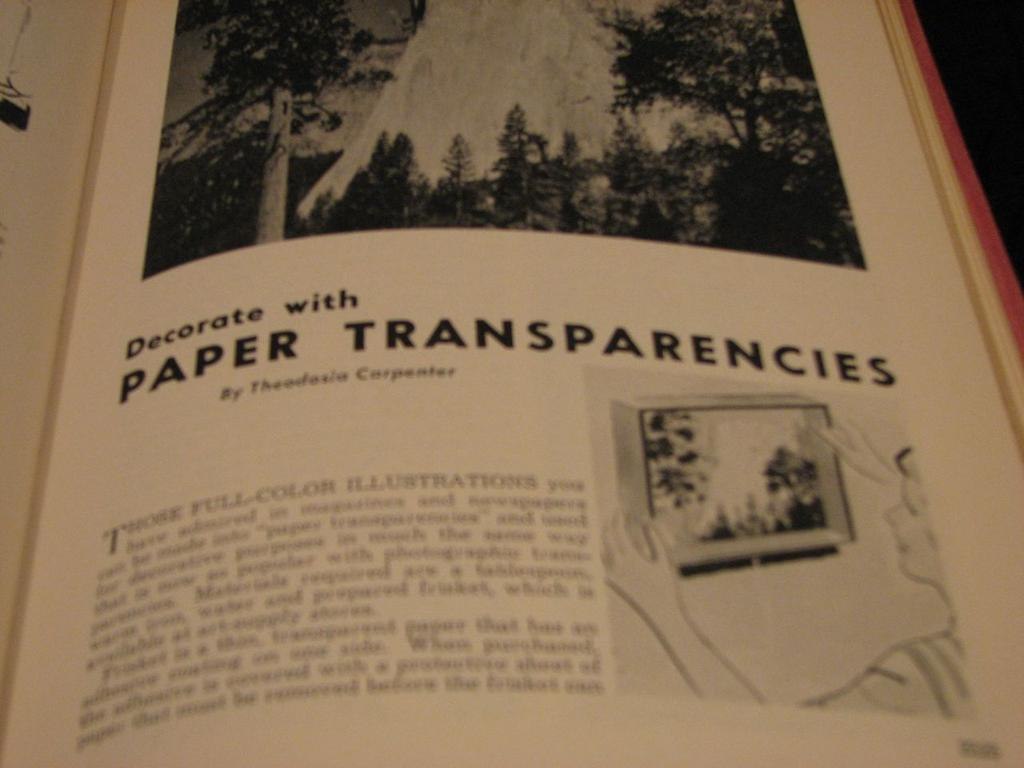Provide a one-sentence caption for the provided image. A book is open to an article on decorating with paper transparencies. 